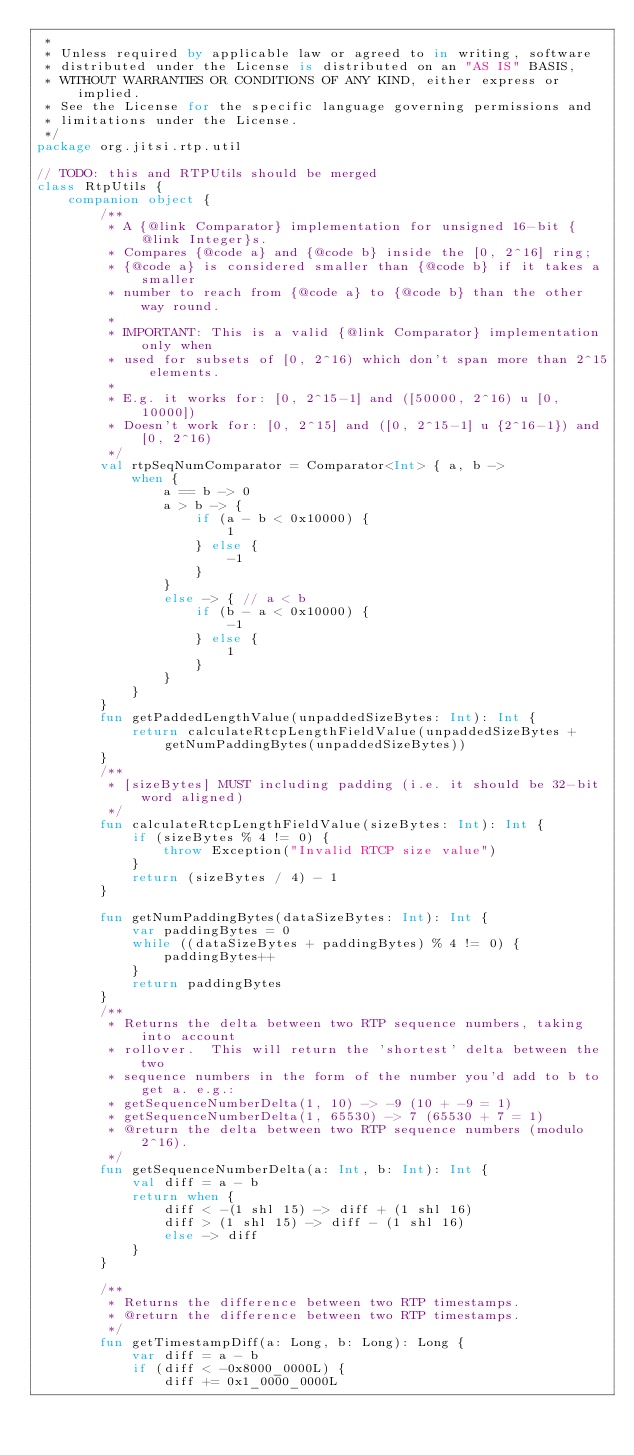Convert code to text. <code><loc_0><loc_0><loc_500><loc_500><_Kotlin_> *
 * Unless required by applicable law or agreed to in writing, software
 * distributed under the License is distributed on an "AS IS" BASIS,
 * WITHOUT WARRANTIES OR CONDITIONS OF ANY KIND, either express or implied.
 * See the License for the specific language governing permissions and
 * limitations under the License.
 */
package org.jitsi.rtp.util

// TODO: this and RTPUtils should be merged
class RtpUtils {
    companion object {
        /**
         * A {@link Comparator} implementation for unsigned 16-bit {@link Integer}s.
         * Compares {@code a} and {@code b} inside the [0, 2^16] ring;
         * {@code a} is considered smaller than {@code b} if it takes a smaller
         * number to reach from {@code a} to {@code b} than the other way round.
         *
         * IMPORTANT: This is a valid {@link Comparator} implementation only when
         * used for subsets of [0, 2^16) which don't span more than 2^15 elements.
         *
         * E.g. it works for: [0, 2^15-1] and ([50000, 2^16) u [0, 10000])
         * Doesn't work for: [0, 2^15] and ([0, 2^15-1] u {2^16-1}) and [0, 2^16)
         */
        val rtpSeqNumComparator = Comparator<Int> { a, b ->
            when {
                a == b -> 0
                a > b -> {
                    if (a - b < 0x10000) {
                        1
                    } else {
                        -1
                    }
                }
                else -> { // a < b
                    if (b - a < 0x10000) {
                        -1
                    } else {
                        1
                    }
                }
            }
        }
        fun getPaddedLengthValue(unpaddedSizeBytes: Int): Int {
            return calculateRtcpLengthFieldValue(unpaddedSizeBytes + getNumPaddingBytes(unpaddedSizeBytes))
        }
        /**
         * [sizeBytes] MUST including padding (i.e. it should be 32-bit word aligned)
         */
        fun calculateRtcpLengthFieldValue(sizeBytes: Int): Int {
            if (sizeBytes % 4 != 0) {
                throw Exception("Invalid RTCP size value")
            }
            return (sizeBytes / 4) - 1
        }

        fun getNumPaddingBytes(dataSizeBytes: Int): Int {
            var paddingBytes = 0
            while ((dataSizeBytes + paddingBytes) % 4 != 0) {
                paddingBytes++
            }
            return paddingBytes
        }
        /**
         * Returns the delta between two RTP sequence numbers, taking into account
         * rollover.  This will return the 'shortest' delta between the two
         * sequence numbers in the form of the number you'd add to b to get a. e.g.:
         * getSequenceNumberDelta(1, 10) -> -9 (10 + -9 = 1)
         * getSequenceNumberDelta(1, 65530) -> 7 (65530 + 7 = 1)
         * @return the delta between two RTP sequence numbers (modulo 2^16).
         */
        fun getSequenceNumberDelta(a: Int, b: Int): Int {
            val diff = a - b
            return when {
                diff < -(1 shl 15) -> diff + (1 shl 16)
                diff > (1 shl 15) -> diff - (1 shl 16)
                else -> diff
            }
        }

        /**
         * Returns the difference between two RTP timestamps.
         * @return the difference between two RTP timestamps.
         */
        fun getTimestampDiff(a: Long, b: Long): Long {
            var diff = a - b
            if (diff < -0x8000_0000L) {
                diff += 0x1_0000_0000L</code> 